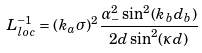Convert formula to latex. <formula><loc_0><loc_0><loc_500><loc_500>L _ { l o c } ^ { - 1 } = ( k _ { a } \sigma ) ^ { 2 } \frac { \alpha _ { - } ^ { 2 } \sin ^ { 2 } ( k _ { b } d _ { b } ) } { 2 d \sin ^ { 2 } ( \kappa d ) }</formula> 